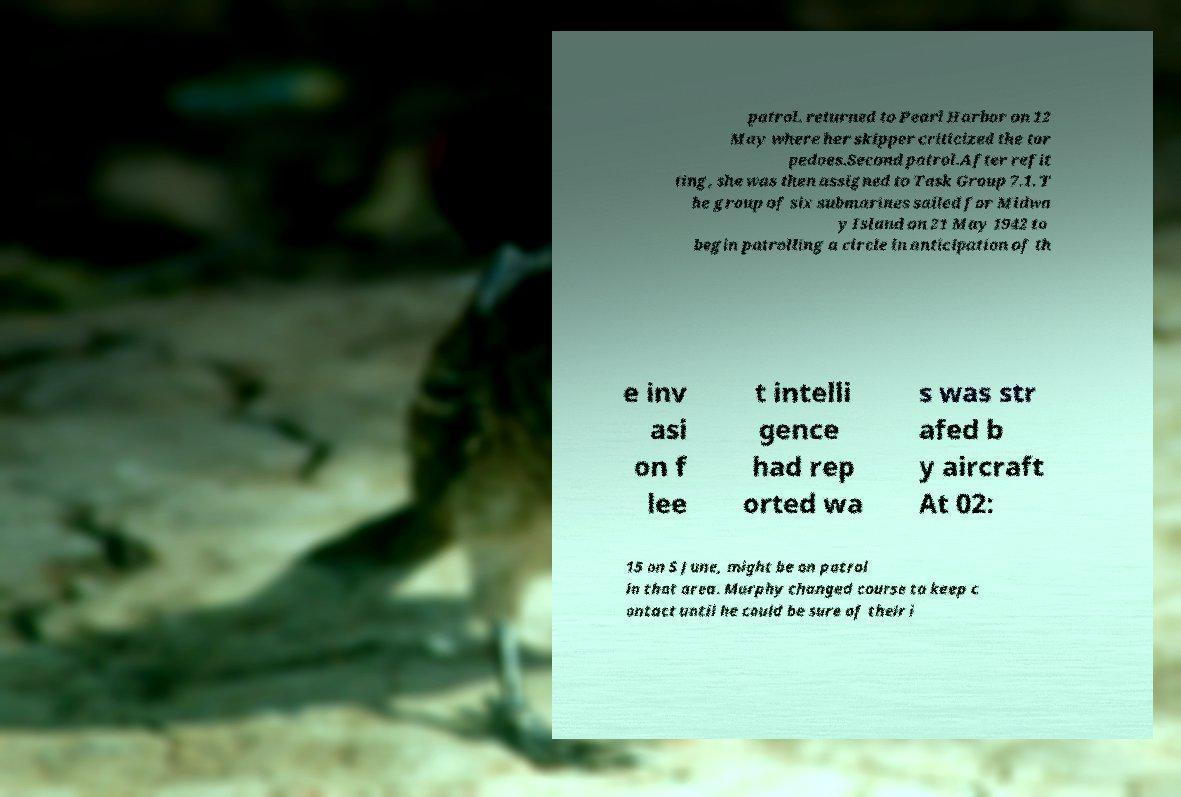Can you read and provide the text displayed in the image?This photo seems to have some interesting text. Can you extract and type it out for me? patrol. returned to Pearl Harbor on 12 May where her skipper criticized the tor pedoes.Second patrol.After refit ting, she was then assigned to Task Group 7.1. T he group of six submarines sailed for Midwa y Island on 21 May 1942 to begin patrolling a circle in anticipation of th e inv asi on f lee t intelli gence had rep orted wa s was str afed b y aircraft At 02: 15 on 5 June, might be on patrol in that area. Murphy changed course to keep c ontact until he could be sure of their i 